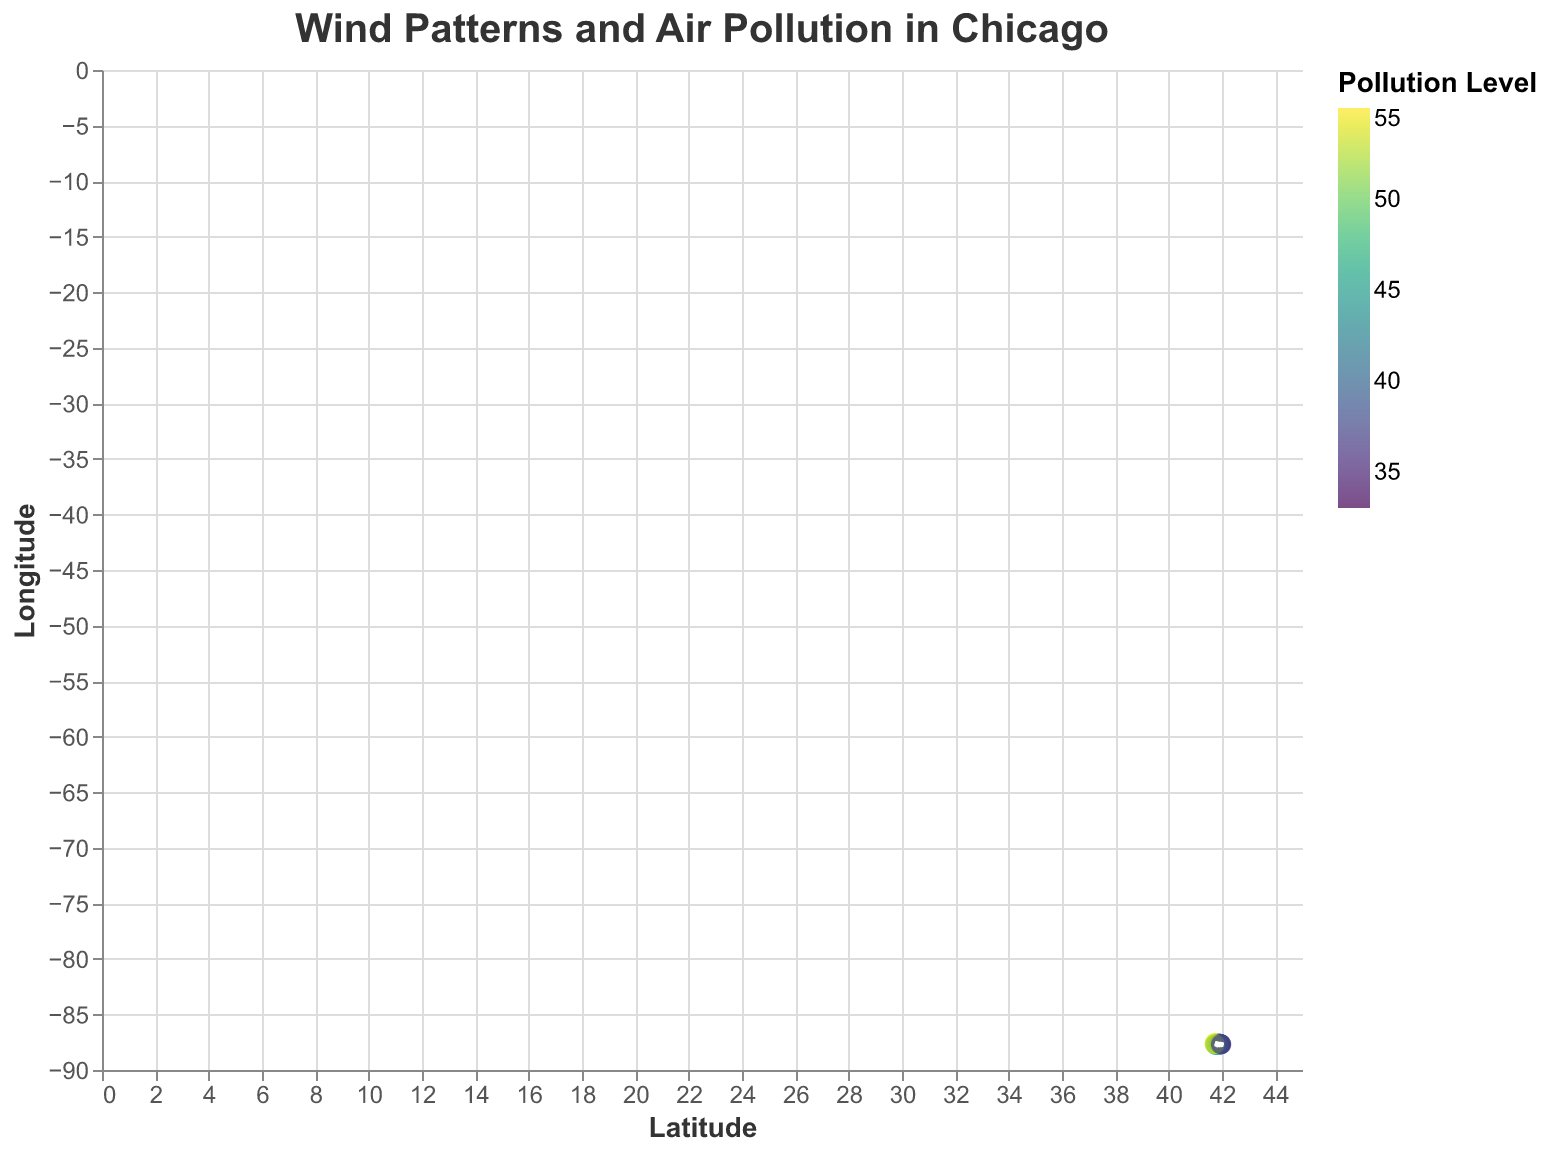What is the title of the figure? The title of the figure is prominently displayed at the top, showing the subject of the plot.
Answer: "Wind Patterns and Air Pollution in Chicago" How many data points are on the plot? By counting the coordinates or points on the plot, we can determine the total number of data points.
Answer: 15 Which neighborhood has the highest pollution level? By looking at the color of the points, with the darkest or most intense color corresponding to the highest pollution level, we can identify the neighborhood.
Answer: 41.7381, -87.5516 (Pollution Level: 55) What's the direction of the wind in the neighborhood with latitude 41.9289 and longitude -87.7090? By examining the direction of the arrow originating from the specified coordinates, we can infer the wind direction. The arrow points in the direction of the wind.
Answer: Northwest What is the average pollution level across all neighborhoods? To find the average pollution level, sum up all the pollution levels and divide by the number of data points. (45 + 38 + 52 + 48 + 41 + 39 + 50 + 35 + 55 + 47 + 33 + 49 + 42 + 53 + 37) / 15 = 44.2
Answer: 44.2 Which neighborhood experiences the most significant wind speed? Wind speed is determined by the length of the arrow. Calculate the wind speed as the vector sum sqrt(u^2 + v^2) for each data point and identify the maximum.
Answer: 41.7508, -87.6145 What is the median pollution level among the neighborhoods? First, list all pollution levels in ascending order and find the middle value. The sorted pollution levels: [33, 35, 37, 38, 39, 41, 42, 45, 47, 48, 49, 50, 52, 53, 55]. The median value is the 8th value in this sorted list.
Answer: 45 Compare the wind speed in neighborhoods with the lowest pollution level and the highest pollution level. Identify the neighborhoods with the lowest (33 at 41.9084, -87.6355) and highest (55 at 41.7381, -87.5516) pollution levels. Then, calculate the wind speed for both using sqrt(u^2 + v^2): (33) sqrt(1.7^2 + 0.8^2) = 1.87, (55) sqrt(2.6^2 + 1.4^2) = 2.99
Answer: Wind speed is higher in the neighborhood with the highest pollution level Which neighborhoods have a pollution level above 50? Identify and list neighborhoods with pollution levels greater than the threshold (50).
Answer: 41.7508, -87.6145; 41.7381, -87.5516; 41.7225, -87.6676 Is there a noticeable trend in wind direction and pollution levels across the neighborhoods? By visually examining the plot, observe if neighborhoods with higher pollution levels show a consistent wind direction pattern compared to those with lower pollution levels.
Answer: There is no clear trend visible 